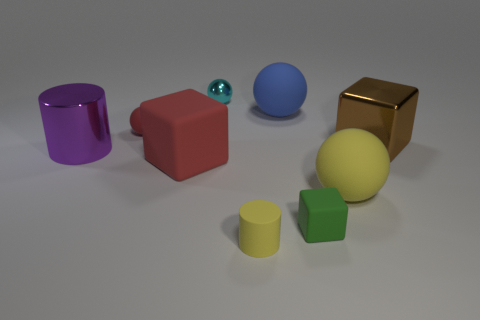Subtract all small cubes. How many cubes are left? 2 Add 1 small metal spheres. How many objects exist? 10 Subtract all cyan spheres. How many spheres are left? 3 Subtract 0 purple spheres. How many objects are left? 9 Subtract all balls. How many objects are left? 5 Subtract 1 cylinders. How many cylinders are left? 1 Subtract all purple balls. Subtract all blue cylinders. How many balls are left? 4 Subtract all yellow cubes. How many green balls are left? 0 Subtract all cyan rubber spheres. Subtract all brown metallic blocks. How many objects are left? 8 Add 5 big yellow rubber objects. How many big yellow rubber objects are left? 6 